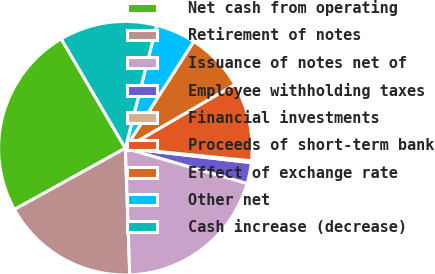<chart> <loc_0><loc_0><loc_500><loc_500><pie_chart><fcel>Net cash from operating<fcel>Retirement of notes<fcel>Issuance of notes net of<fcel>Employee withholding taxes<fcel>Financial investments<fcel>Proceeds of short-term bank<fcel>Effect of exchange rate<fcel>Other net<fcel>Cash increase (decrease)<nl><fcel>24.6%<fcel>17.52%<fcel>19.96%<fcel>2.67%<fcel>0.23%<fcel>9.98%<fcel>7.54%<fcel>5.1%<fcel>12.41%<nl></chart> 